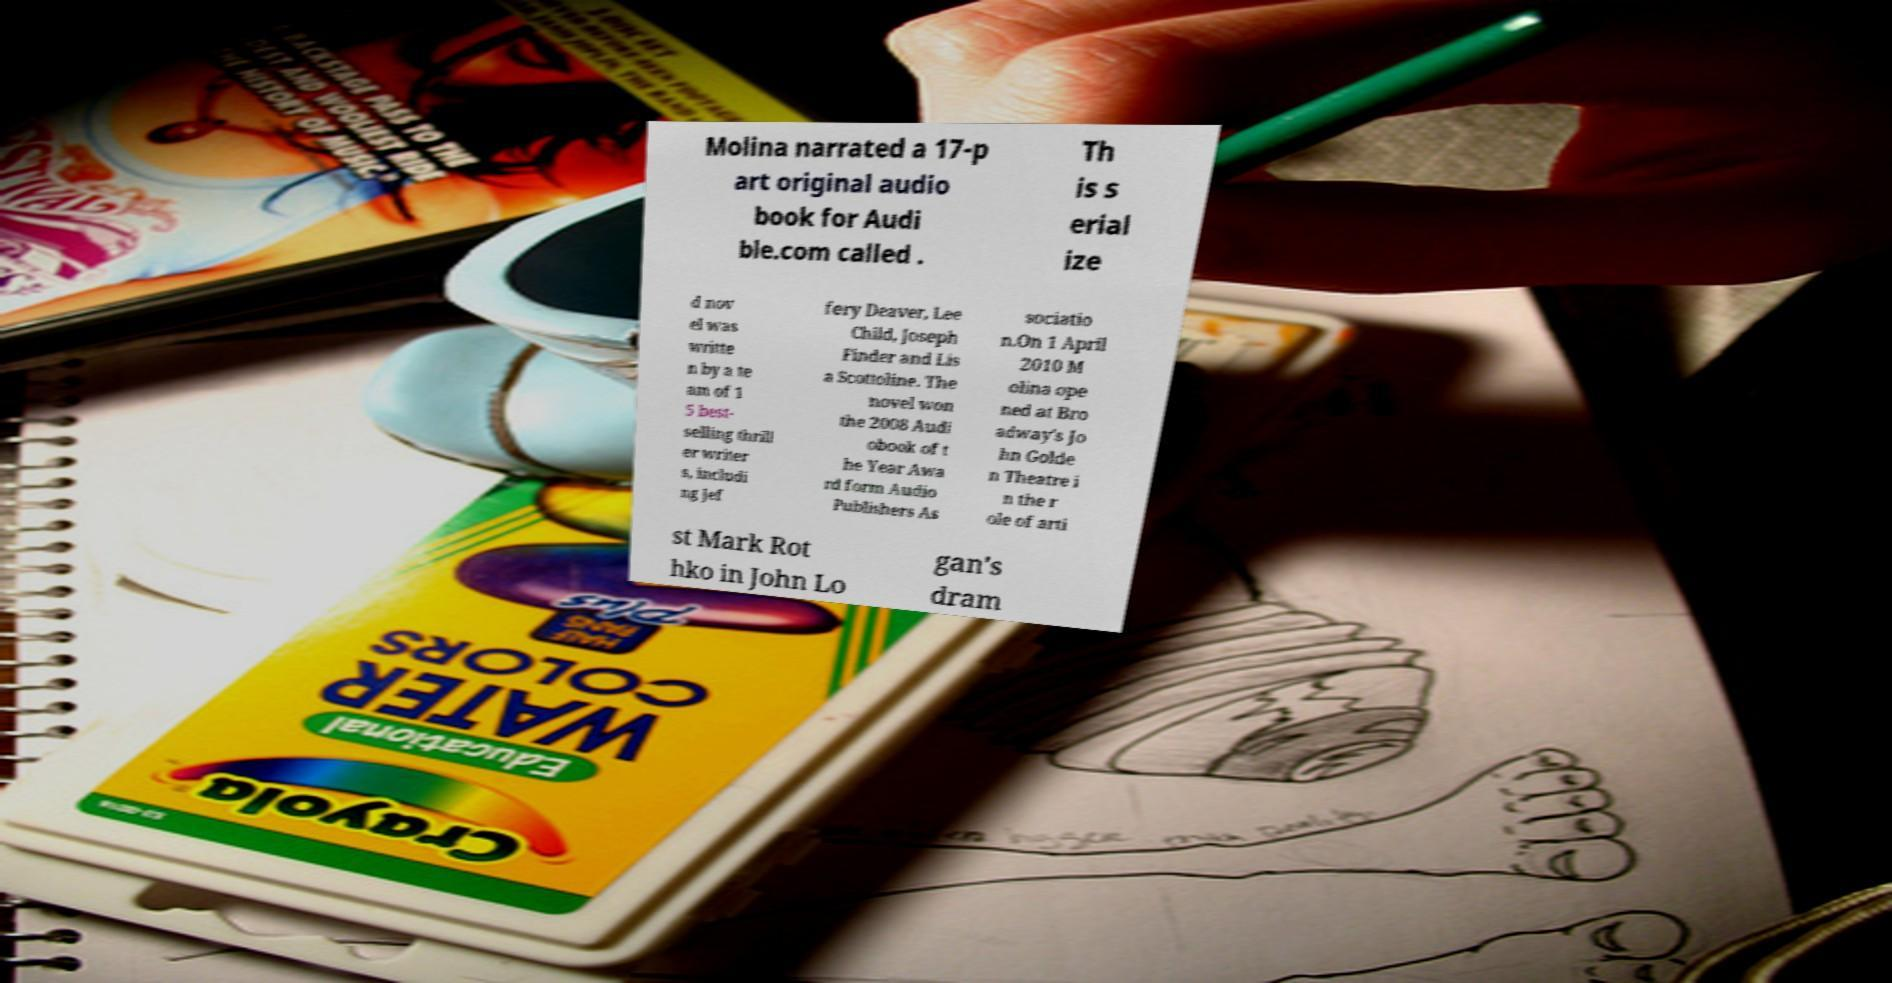There's text embedded in this image that I need extracted. Can you transcribe it verbatim? Molina narrated a 17-p art original audio book for Audi ble.com called . Th is s erial ize d nov el was writte n by a te am of 1 5 best- selling thrill er writer s, includi ng Jef fery Deaver, Lee Child, Joseph Finder and Lis a Scottoline. The novel won the 2008 Audi obook of t he Year Awa rd form Audio Publishers As sociatio n.On 1 April 2010 M olina ope ned at Bro adway's Jo hn Golde n Theatre i n the r ole of arti st Mark Rot hko in John Lo gan's dram 